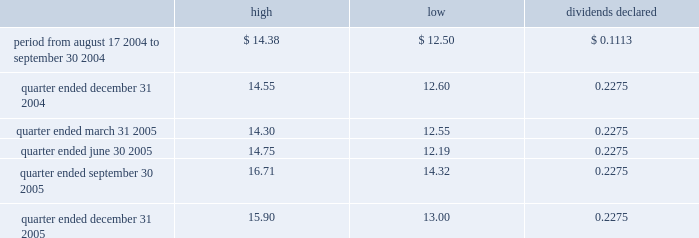Part ii item 5 .
Market for registrant 2019s common equity and related stockholder matters market information our common stock has been traded on the new york stock exchange ( 2018 2018nyse 2019 2019 ) under the symbol 2018 2018exr 2019 2019 since our ipo on august 17 , 2004 .
Prior to that time there was no public market for our common stock .
The table sets forth , for the periods indicated , the high and low bid price for our common stock as reported by the nyse and the per share dividends declared : dividends high low declared .
On february 28 , 2006 , the closing price of our common stock as reported by the nyse was $ 15.00 .
At february 28 , 2006 , we had 166 holders of record of our common stock .
Holders of shares of common stock are entitled to receive distributions when declared by our board of directors out of any assets legally available for that purpose .
As a reit , we are required to distribute at least 90% ( 90 % ) of our 2018 2018reit taxable income 2019 2019 is generally equivalent to our net taxable ordinary income , determined without regard to the deduction for dividends paid , to our stockholders annually in order to maintain our reit qualifications for u.s .
Federal income tax purposes .
Unregistered sales of equity securities and use of proceeds on june 20 , 2005 , we completed the sale of 6200000 shares of our common stock , $ .01 par value , for $ 83514 , which we reported in a current report on form 8-k filed with the securities and exchange commission on june 24 , 2005 .
We used the proceeds for general corporate purposes , including debt repayment .
The shares were issued pursuant to an exemption from registration under the securities act of 1933 , as amended. .
What was the dividend yield for the quarter ended march 31 , 2005 using the high bid price? 
Rationale: this gives and example of the yield for the full year based on the worst price that could have been obtained on the bid for the quarter . it also compares with the previous answer as a risk measure .
Computations: ((0.2275 * 4) / 14.30)
Answer: 0.06364. 